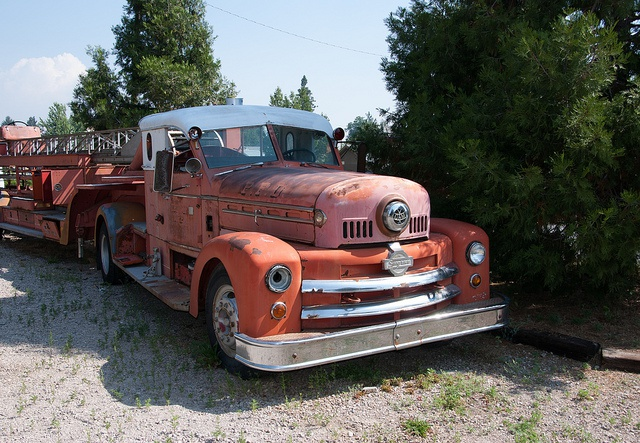Describe the objects in this image and their specific colors. I can see a truck in lightblue, black, maroon, gray, and darkgray tones in this image. 